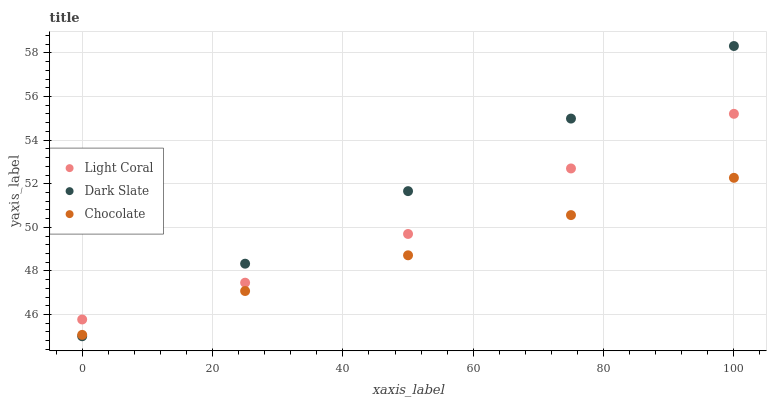Does Chocolate have the minimum area under the curve?
Answer yes or no. Yes. Does Dark Slate have the maximum area under the curve?
Answer yes or no. Yes. Does Dark Slate have the minimum area under the curve?
Answer yes or no. No. Does Chocolate have the maximum area under the curve?
Answer yes or no. No. Is Dark Slate the smoothest?
Answer yes or no. Yes. Is Light Coral the roughest?
Answer yes or no. Yes. Is Chocolate the smoothest?
Answer yes or no. No. Is Chocolate the roughest?
Answer yes or no. No. Does Dark Slate have the lowest value?
Answer yes or no. Yes. Does Chocolate have the lowest value?
Answer yes or no. No. Does Dark Slate have the highest value?
Answer yes or no. Yes. Does Chocolate have the highest value?
Answer yes or no. No. Is Chocolate less than Light Coral?
Answer yes or no. Yes. Is Light Coral greater than Chocolate?
Answer yes or no. Yes. Does Light Coral intersect Dark Slate?
Answer yes or no. Yes. Is Light Coral less than Dark Slate?
Answer yes or no. No. Is Light Coral greater than Dark Slate?
Answer yes or no. No. Does Chocolate intersect Light Coral?
Answer yes or no. No. 